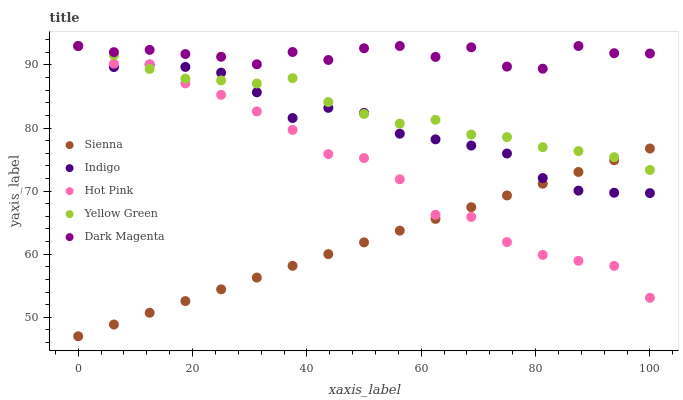Does Sienna have the minimum area under the curve?
Answer yes or no. Yes. Does Dark Magenta have the maximum area under the curve?
Answer yes or no. Yes. Does Hot Pink have the minimum area under the curve?
Answer yes or no. No. Does Hot Pink have the maximum area under the curve?
Answer yes or no. No. Is Sienna the smoothest?
Answer yes or no. Yes. Is Dark Magenta the roughest?
Answer yes or no. Yes. Is Hot Pink the smoothest?
Answer yes or no. No. Is Hot Pink the roughest?
Answer yes or no. No. Does Sienna have the lowest value?
Answer yes or no. Yes. Does Hot Pink have the lowest value?
Answer yes or no. No. Does Dark Magenta have the highest value?
Answer yes or no. Yes. Is Sienna less than Dark Magenta?
Answer yes or no. Yes. Is Dark Magenta greater than Sienna?
Answer yes or no. Yes. Does Indigo intersect Yellow Green?
Answer yes or no. Yes. Is Indigo less than Yellow Green?
Answer yes or no. No. Is Indigo greater than Yellow Green?
Answer yes or no. No. Does Sienna intersect Dark Magenta?
Answer yes or no. No. 